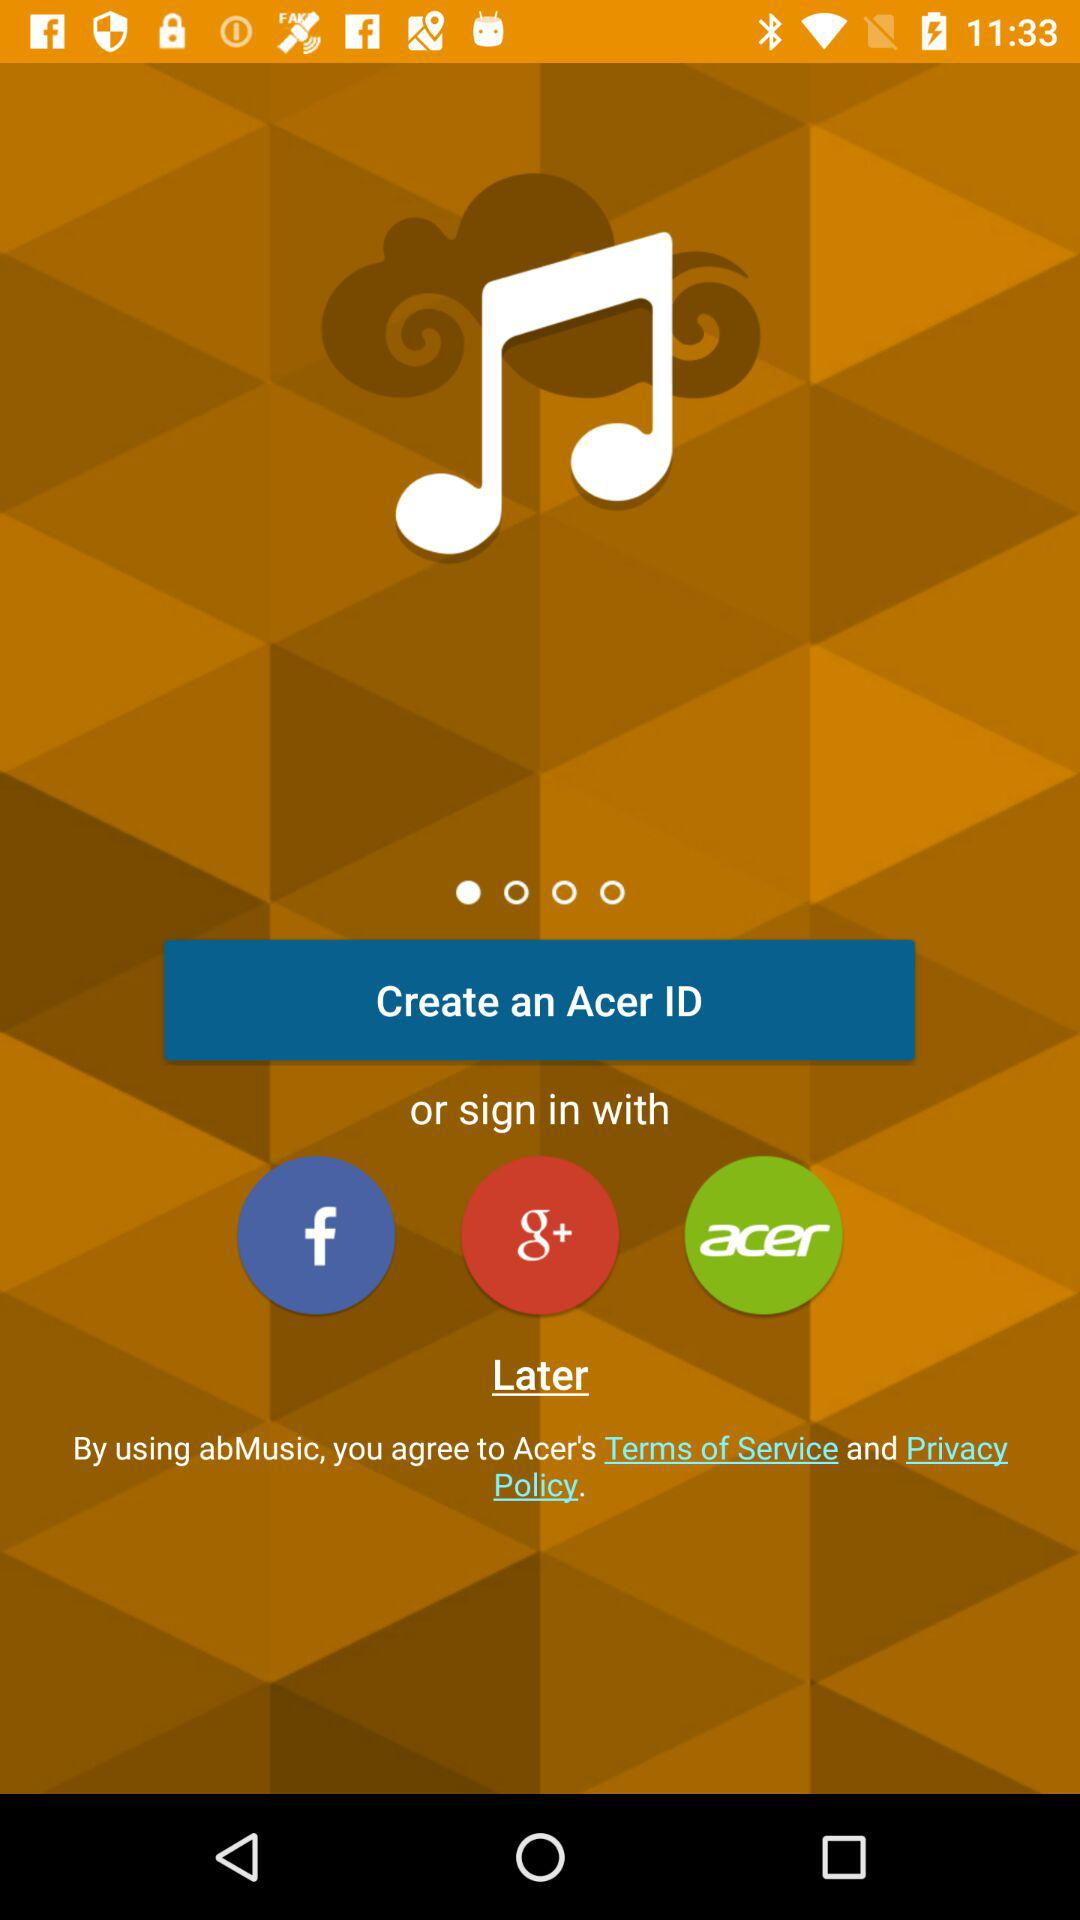What is the name of the application? The name of the applications are "abMusic" and "Acer". 